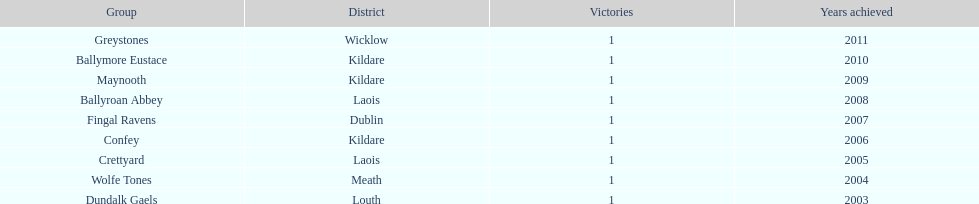What is the number of wins for each team 1. 